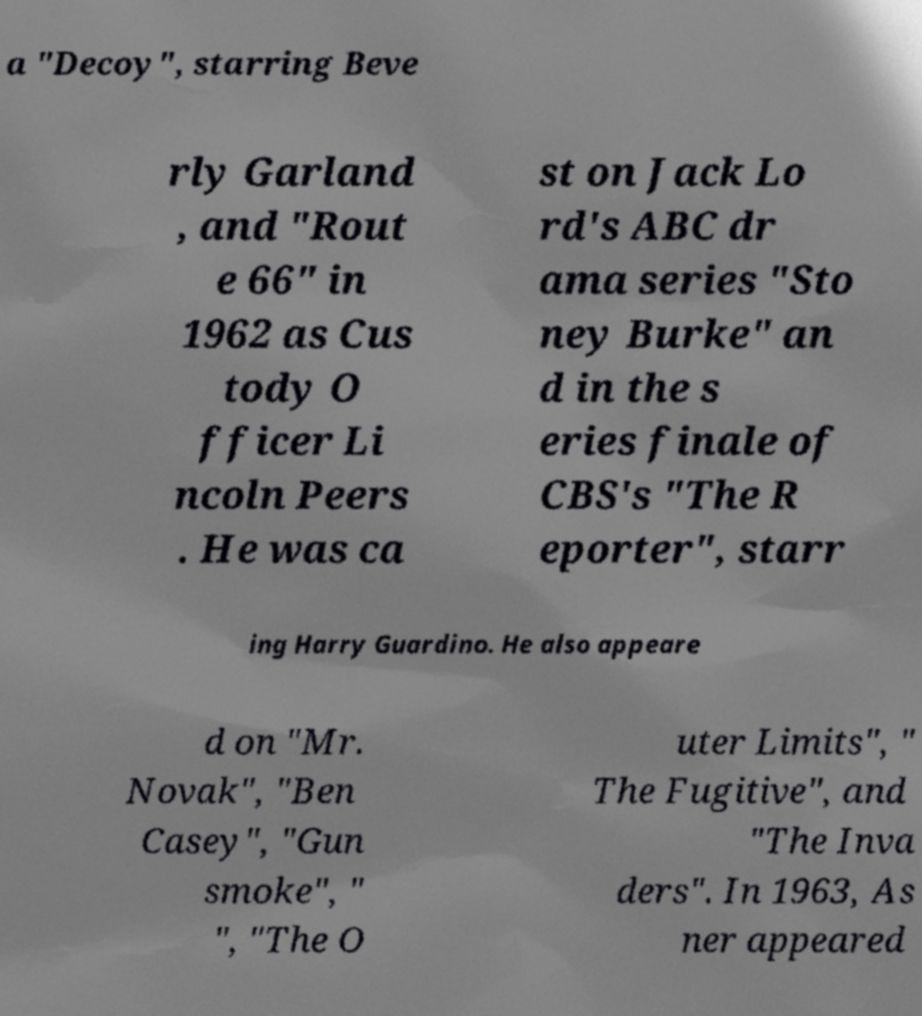Please read and relay the text visible in this image. What does it say? a "Decoy", starring Beve rly Garland , and "Rout e 66" in 1962 as Cus tody O fficer Li ncoln Peers . He was ca st on Jack Lo rd's ABC dr ama series "Sto ney Burke" an d in the s eries finale of CBS's "The R eporter", starr ing Harry Guardino. He also appeare d on "Mr. Novak", "Ben Casey", "Gun smoke", " ", "The O uter Limits", " The Fugitive", and "The Inva ders". In 1963, As ner appeared 